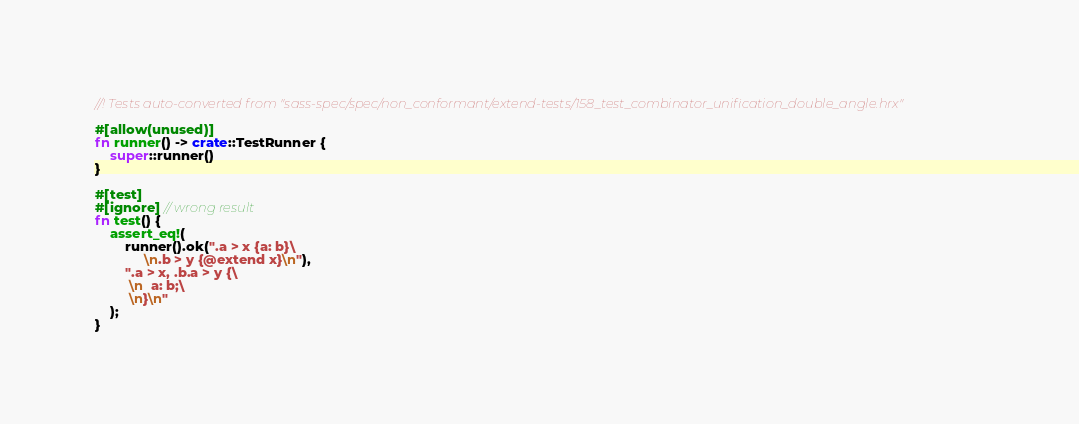Convert code to text. <code><loc_0><loc_0><loc_500><loc_500><_Rust_>//! Tests auto-converted from "sass-spec/spec/non_conformant/extend-tests/158_test_combinator_unification_double_angle.hrx"

#[allow(unused)]
fn runner() -> crate::TestRunner {
    super::runner()
}

#[test]
#[ignore] // wrong result
fn test() {
    assert_eq!(
        runner().ok(".a > x {a: b}\
             \n.b > y {@extend x}\n"),
        ".a > x, .b.a > y {\
         \n  a: b;\
         \n}\n"
    );
}
</code> 